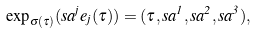<formula> <loc_0><loc_0><loc_500><loc_500>\exp _ { \sigma ( \tau ) } ( s a ^ { j } e _ { j } ( \tau ) ) = ( \tau , s a ^ { 1 } , s a ^ { 2 } , s a ^ { 3 } ) ,</formula> 